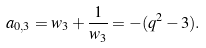Convert formula to latex. <formula><loc_0><loc_0><loc_500><loc_500>a _ { 0 , 3 } = w _ { 3 } + \frac { 1 } { w _ { 3 } } = - ( q ^ { 2 } - 3 ) .</formula> 